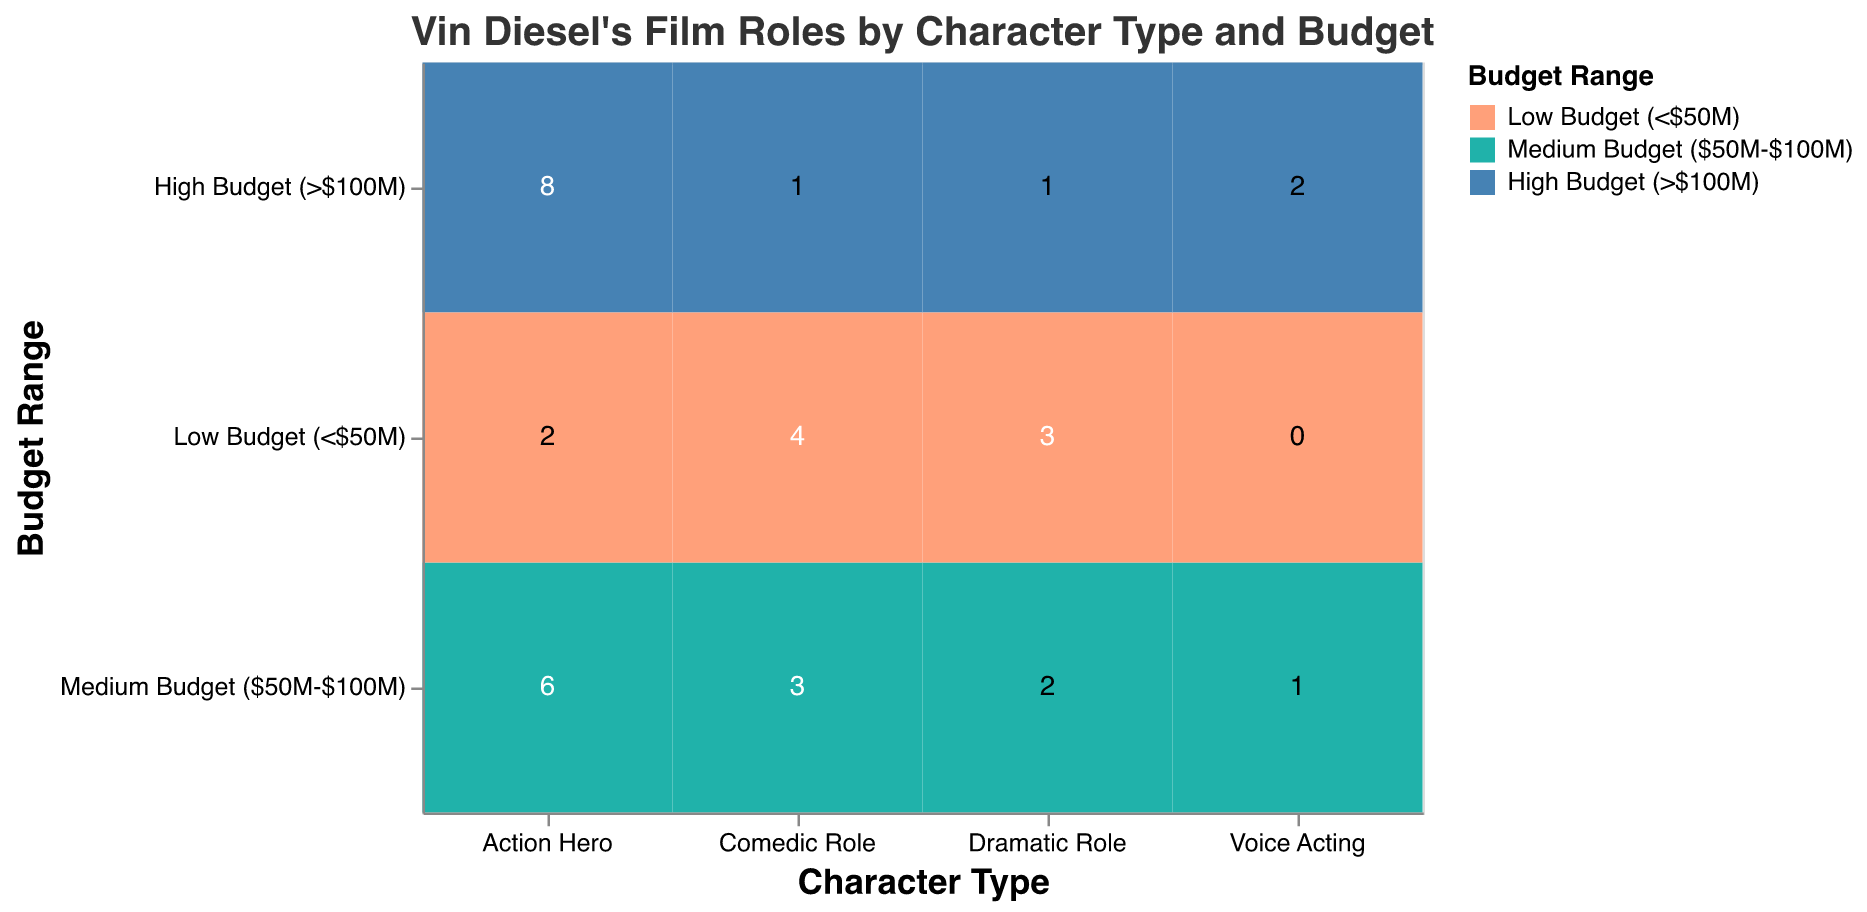What's the title of the figure? The title is usually at the top of the figure, and it directly describes the content of the visualization.
Answer: Vin Diesel's Film Roles by Character Type and Budget Which role has the highest count in Vin Diesel's filmography for High Budget movies? Look for the count associated with each character type in the "High Budget (>$100M)" category and identify the maximum.
Answer: Action Hero How many total film roles has Vin Diesel played in the Comedic Role category? Sum the counts of Vin Diesel's film roles in Comedic Role across all budget ranges: 1 (high) + 3 (medium) + 4 (low).
Answer: 8 Which budget range is the least represented in Vin Diesel's Voice Acting roles? Identify the budget range with the smallest count for Voice Acting.
Answer: Low Budget (<$50M) What is the total count of Vin Diesel’s film roles that fall into the Medium Budget ($50M-$100M) category? Sum the counts of all character types within the Medium Budget range: 6 (Action Hero) + 3 (Comedic Role) + 2 (Dramatic Role) + 1 (Voice Acting).
Answer: 12 Compare the count of Action Hero roles in High Budget and Low Budget movies. What is the difference between them? Subtract the count of Low Budget Action Hero roles from the count of High Budget Action Hero roles: 8 (High Budget) - 2 (Low Budget).
Answer: 6 Which character type has the most diverse representation across different budget ranges? Identify the character type that has roles in all three budget ranges (High, Medium, and Low).
Answer: Action Hero How many more Action Hero roles are there in Medium Budget movies compared to Dramatic Roles? Subtract the count of Medium Budget Dramatic Roles from that of Medium Budget Action Hero roles: 6 - 2.
Answer: 4 Among the character types represented in High Budget films, which has the fewest roles? Look at the counts of each character type in the High Budget range and identify the smallest count.
Answer: Comedic Role / Dramatic Role (both have 1) How does the number of Comedic roles in Medium Budget films compare to those in Low Budget films? Compare the counts of Comedic Role in Medium Budget movies to those in Low Budget movies: 3 (Medium) vs. 4 (Low).
Answer: Fewer in Medium 